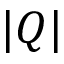<formula> <loc_0><loc_0><loc_500><loc_500>| Q |</formula> 